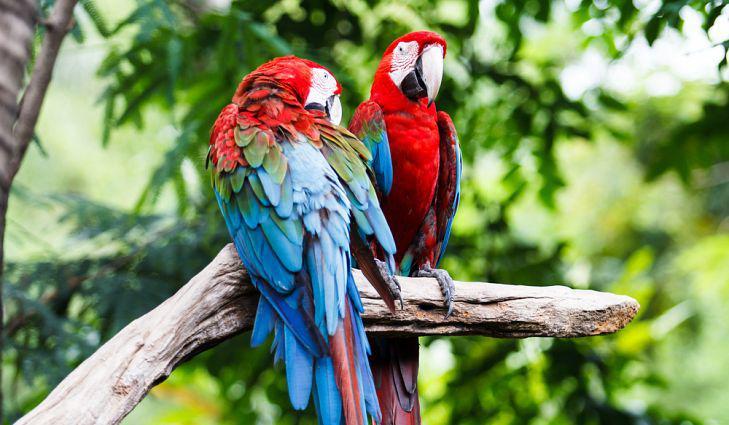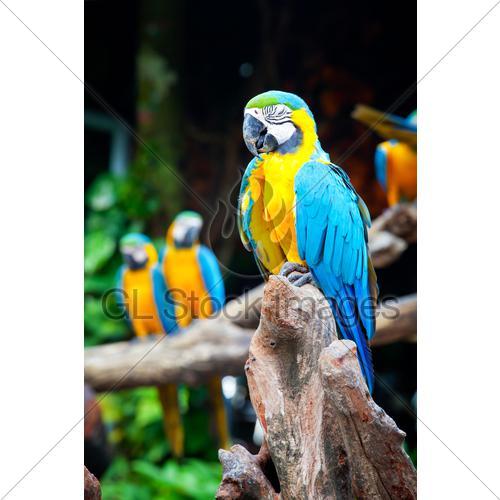The first image is the image on the left, the second image is the image on the right. Analyze the images presented: Is the assertion "All of the birds are outside." valid? Answer yes or no. Yes. The first image is the image on the left, the second image is the image on the right. Assess this claim about the two images: "Each image contains a single parrot, and each parrot has its eye squeezed tightly shut.". Correct or not? Answer yes or no. No. 